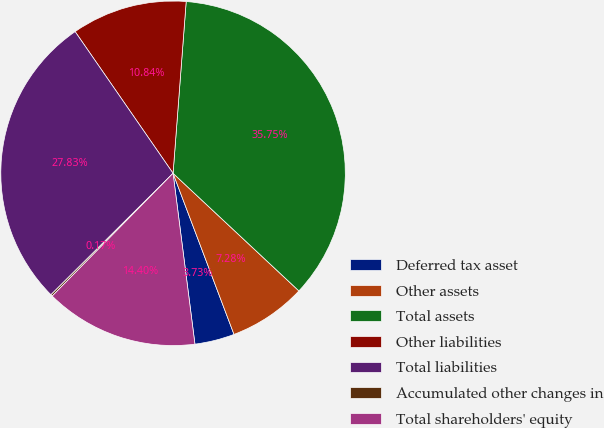Convert chart to OTSL. <chart><loc_0><loc_0><loc_500><loc_500><pie_chart><fcel>Deferred tax asset<fcel>Other assets<fcel>Total assets<fcel>Other liabilities<fcel>Total liabilities<fcel>Accumulated other changes in<fcel>Total shareholders' equity<nl><fcel>3.73%<fcel>7.28%<fcel>35.75%<fcel>10.84%<fcel>27.83%<fcel>0.17%<fcel>14.4%<nl></chart> 